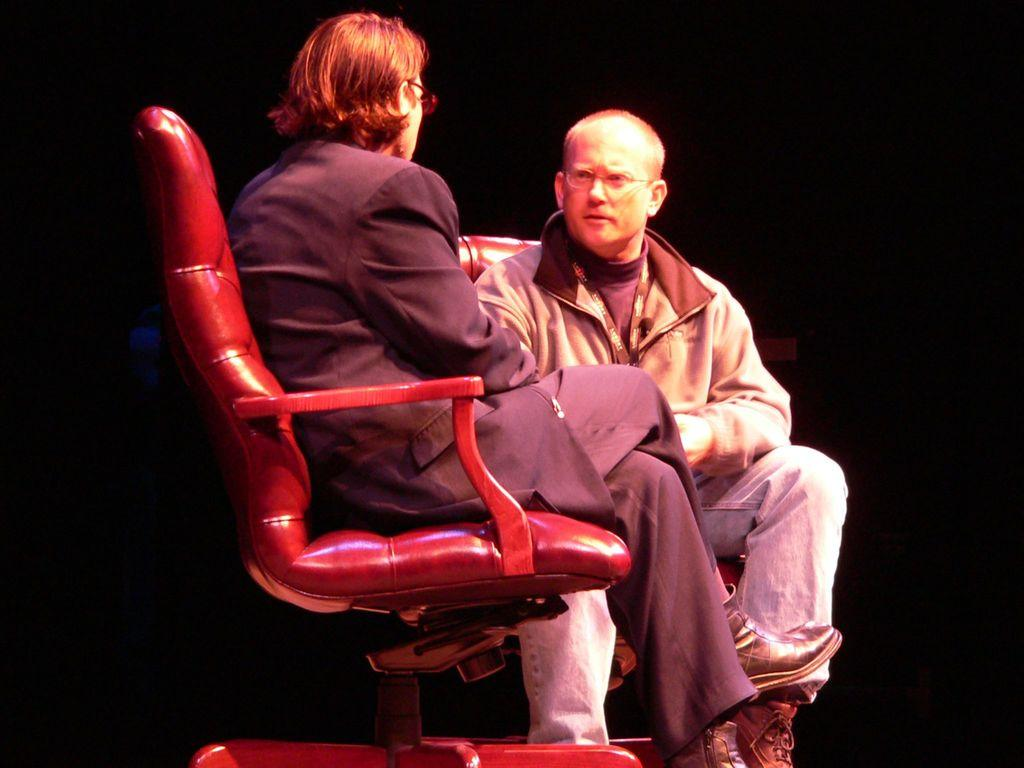How many people are in the image? There are two people in the image. What are the people wearing? Both people are wearing spectacles. What are the people doing in the image? The people are sitting on chairs. What is the color of the background in the image? The background of the image is dark. What type of map can be seen in the image? There is no map present in the image. Is there any smoke visible in the image? There is no smoke visible in the image. 